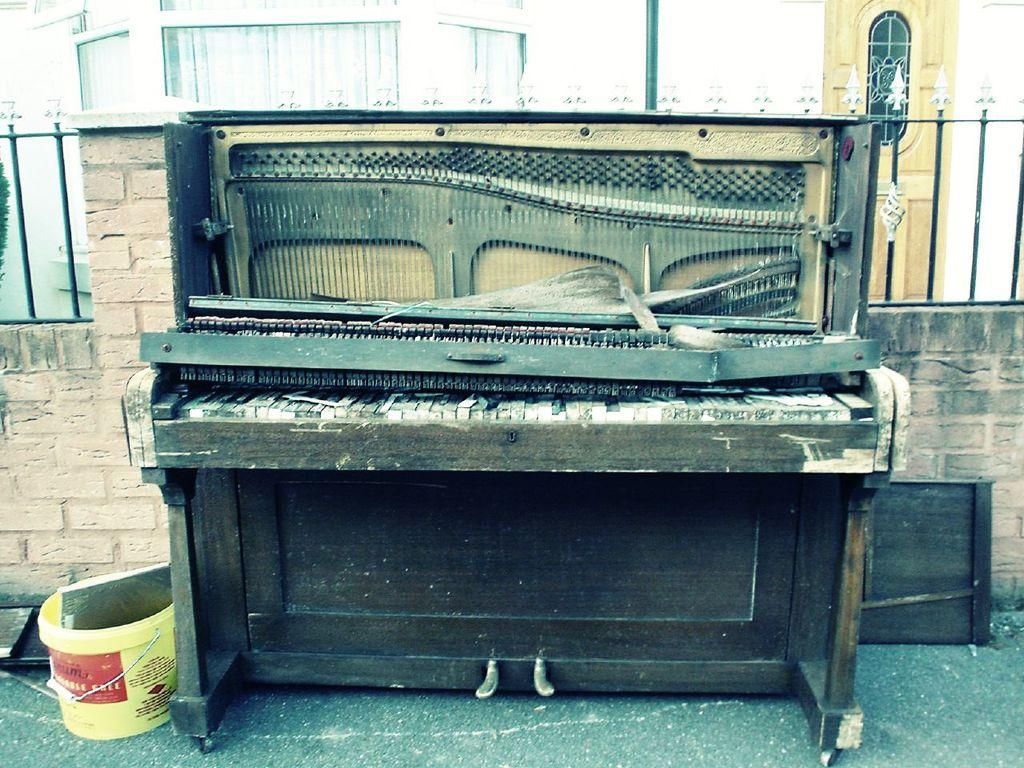What type of musical instrument is in the picture? There is an old piano in the picture. Where is the piano located in relation to the wall? The piano is kept near a wall. What object is also near the wall? There is a bucket near the wall. What can be seen in the background of the image? There is a building visible in the image. How many toes are visible on the piano in the image? There are no toes visible in the image, as the piano is an inanimate object and does not have toes. 